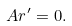Convert formula to latex. <formula><loc_0><loc_0><loc_500><loc_500>A r ^ { \prime } = 0 .</formula> 